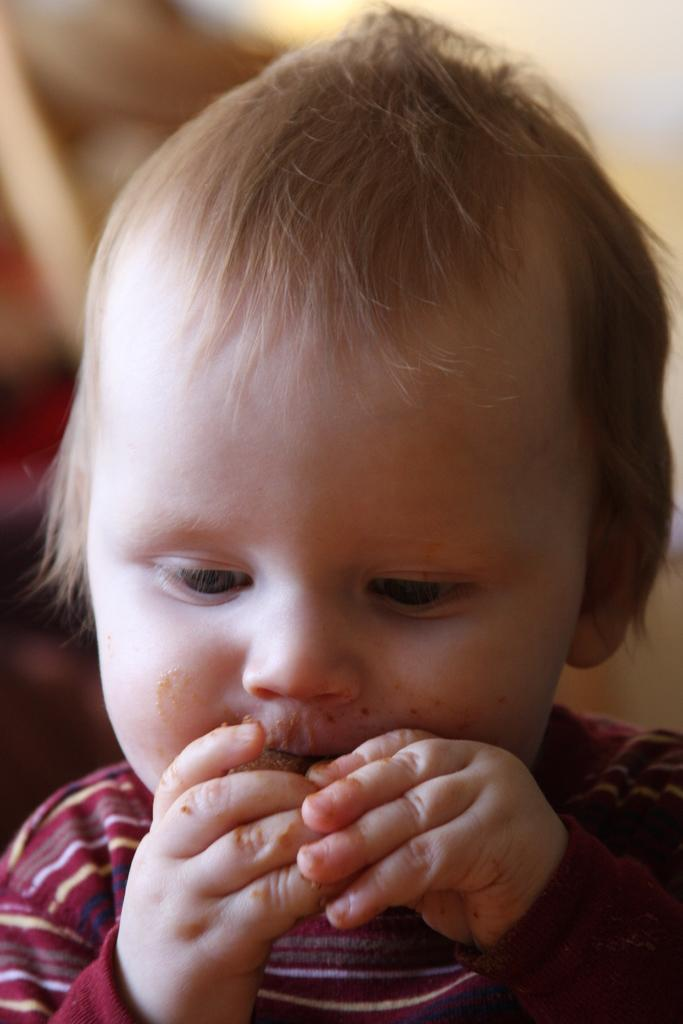What is the main subject of the image? There is a child in the image. What is the child doing in the image? The child is holding food in the image. Can you describe the background of the image? The background of the image is blurry. What type of root can be seen in the image? There is no root present in the image. 